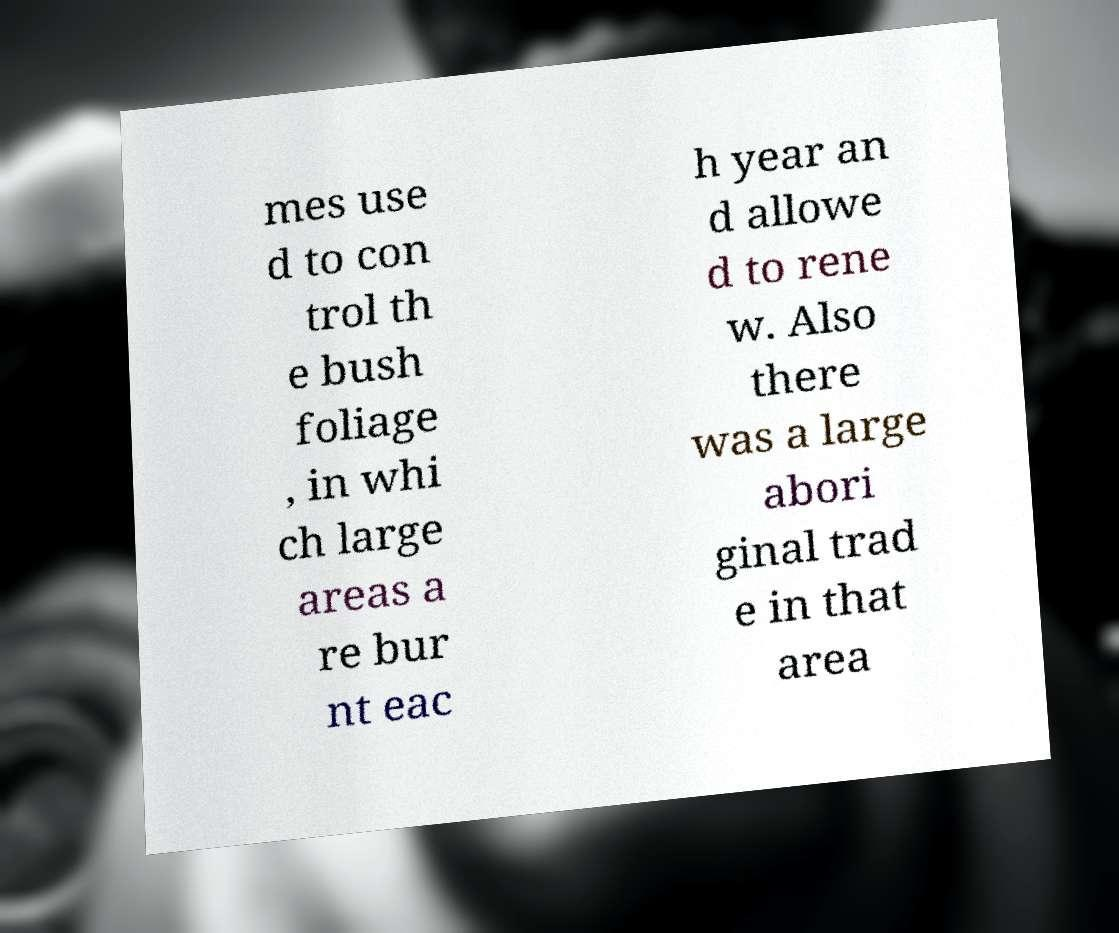Please read and relay the text visible in this image. What does it say? mes use d to con trol th e bush foliage , in whi ch large areas a re bur nt eac h year an d allowe d to rene w. Also there was a large abori ginal trad e in that area 